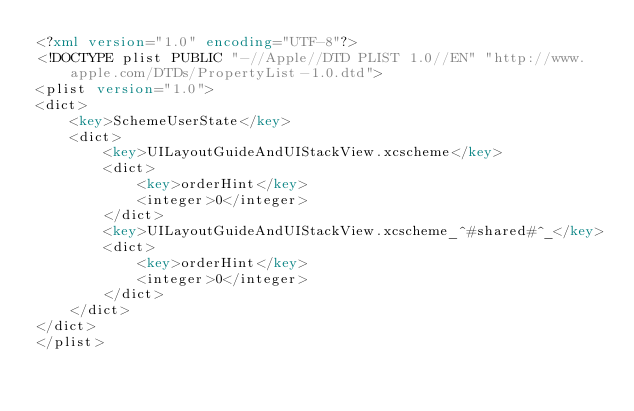<code> <loc_0><loc_0><loc_500><loc_500><_XML_><?xml version="1.0" encoding="UTF-8"?>
<!DOCTYPE plist PUBLIC "-//Apple//DTD PLIST 1.0//EN" "http://www.apple.com/DTDs/PropertyList-1.0.dtd">
<plist version="1.0">
<dict>
	<key>SchemeUserState</key>
	<dict>
		<key>UILayoutGuideAndUIStackView.xcscheme</key>
		<dict>
			<key>orderHint</key>
			<integer>0</integer>
		</dict>
		<key>UILayoutGuideAndUIStackView.xcscheme_^#shared#^_</key>
		<dict>
			<key>orderHint</key>
			<integer>0</integer>
		</dict>
	</dict>
</dict>
</plist>
</code> 